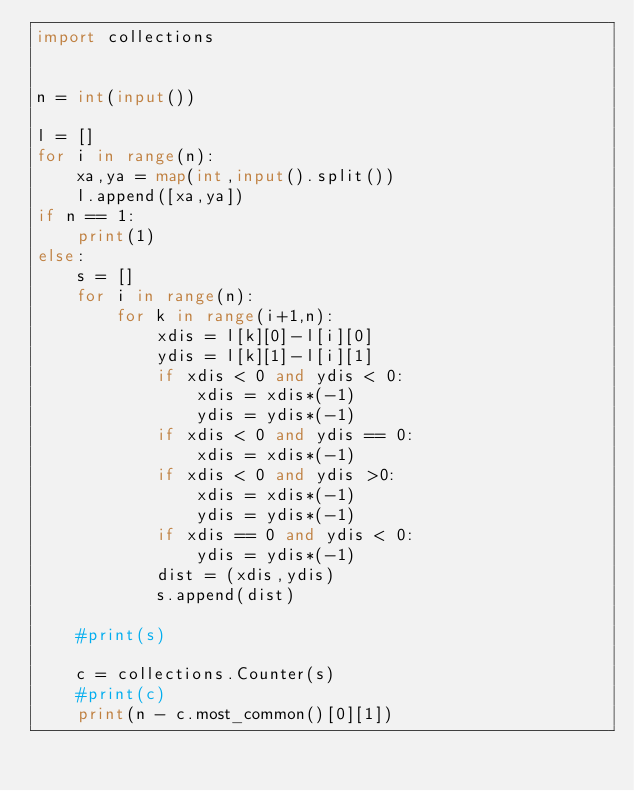Convert code to text. <code><loc_0><loc_0><loc_500><loc_500><_Python_>import collections


n = int(input())

l = []
for i in range(n):
    xa,ya = map(int,input().split())
    l.append([xa,ya])
if n == 1:
    print(1)
else:
    s = []
    for i in range(n):
        for k in range(i+1,n):
            xdis = l[k][0]-l[i][0]
            ydis = l[k][1]-l[i][1]
            if xdis < 0 and ydis < 0:
                xdis = xdis*(-1)
                ydis = ydis*(-1)
            if xdis < 0 and ydis == 0:
                xdis = xdis*(-1)
            if xdis < 0 and ydis >0:
                xdis = xdis*(-1)
                ydis = ydis*(-1)
            if xdis == 0 and ydis < 0:
                ydis = ydis*(-1)
            dist = (xdis,ydis)
            s.append(dist)

    #print(s)

    c = collections.Counter(s)
    #print(c)
    print(n - c.most_common()[0][1])
</code> 